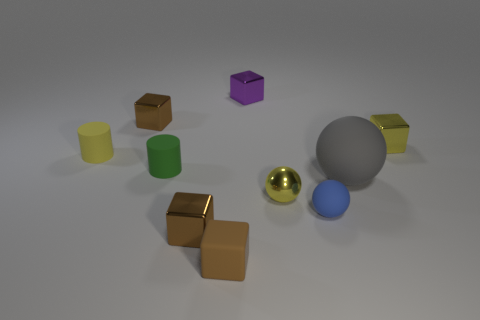Is the gray rubber sphere the same size as the purple metallic cube?
Your answer should be compact. No. How many objects are either brown shiny blocks that are behind the large gray object or yellow shiny objects?
Your response must be concise. 3. What shape is the brown metal object that is behind the yellow object that is to the left of the tiny brown matte thing?
Give a very brief answer. Cube. There is a gray object; does it have the same size as the yellow thing that is behind the yellow matte cylinder?
Your response must be concise. No. There is a small brown object behind the gray sphere; what material is it?
Provide a short and direct response. Metal. What number of cubes are both right of the purple cube and to the left of the tiny rubber block?
Your answer should be compact. 0. There is a yellow cube that is the same size as the purple block; what material is it?
Make the answer very short. Metal. There is a brown object behind the yellow block; is it the same size as the matte object left of the green rubber object?
Make the answer very short. Yes. Are there any small yellow metal balls left of the tiny yellow cylinder?
Offer a terse response. No. There is a shiny block in front of the small cube that is to the right of the blue matte object; what color is it?
Your answer should be very brief. Brown. 